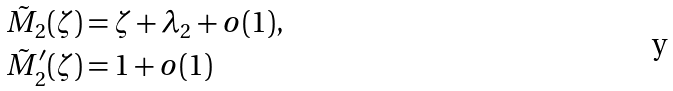<formula> <loc_0><loc_0><loc_500><loc_500>{ \tilde { M } } _ { 2 } ( \zeta ) & = \zeta + \lambda _ { 2 } + o ( 1 ) , \\ { \tilde { M } } _ { 2 } ^ { \prime } ( \zeta ) & = 1 + o ( 1 )</formula> 